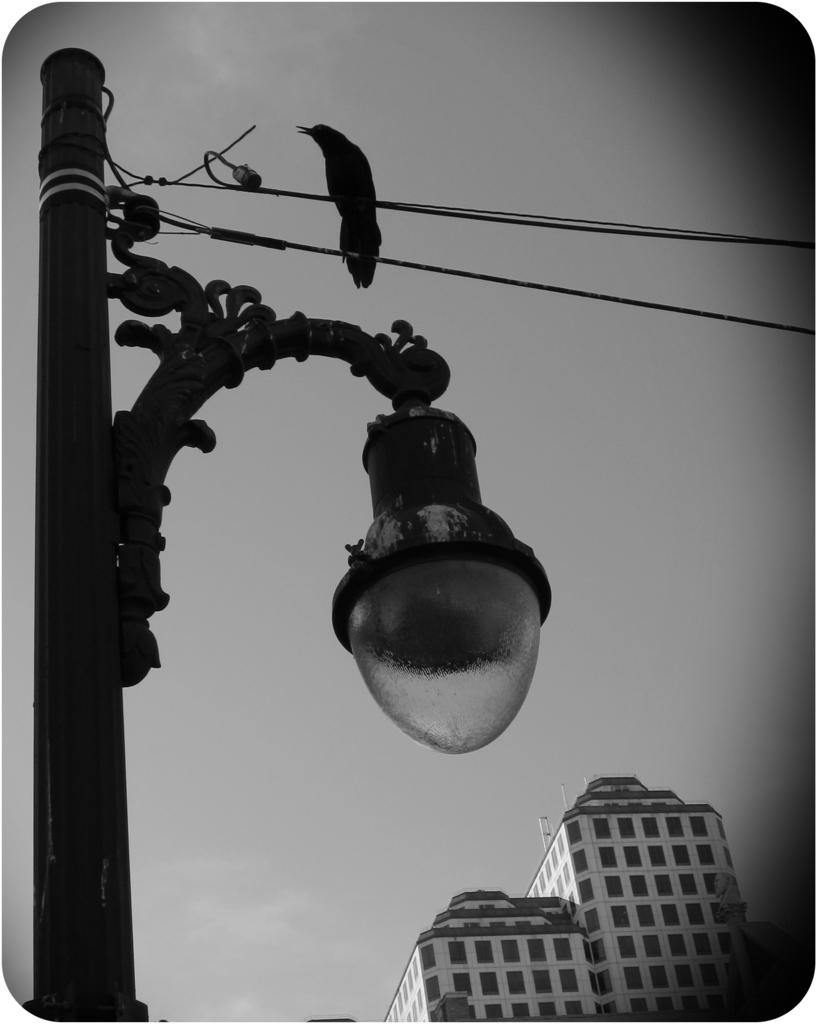What structure can be seen in the image? There is a light pole in the image. What else is present in the image besides the light pole? Wires and buildings are present in the image. What is visible in the background of the image? The sky is visible in the image. Can you describe the bird in the image? A bird is on a wire in the image. What is the color scheme of the image? The image is in black and white. Who is the minister in the image? There is no minister present in the image. What type of room is depicted in the image? The image does not depict a room; it shows an outdoor scene. 